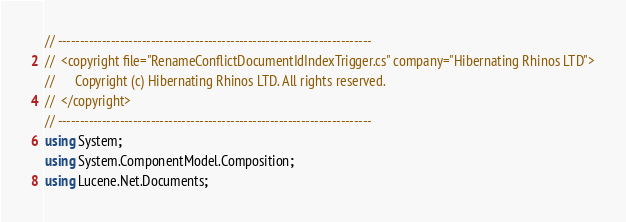Convert code to text. <code><loc_0><loc_0><loc_500><loc_500><_C#_>// -----------------------------------------------------------------------
//  <copyright file="RenameConflictDocumentIdIndexTrigger.cs" company="Hibernating Rhinos LTD">
//      Copyright (c) Hibernating Rhinos LTD. All rights reserved.
//  </copyright>
// -----------------------------------------------------------------------
using System;
using System.ComponentModel.Composition;
using Lucene.Net.Documents;</code> 